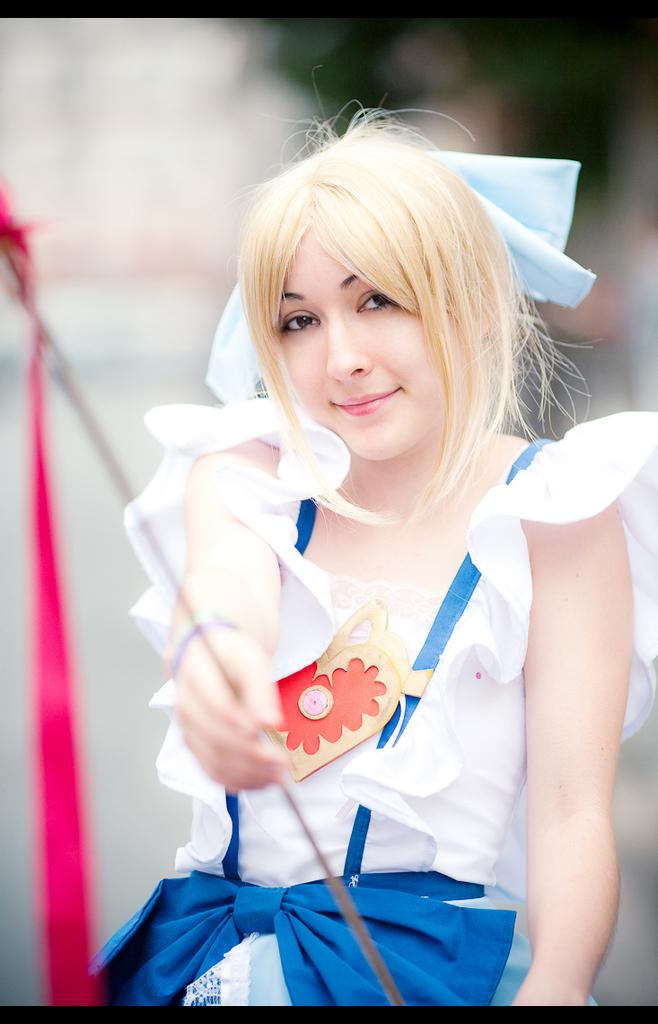Who is the main subject in the image? There is a girl in the image. What is the girl holding in the image? The girl is holding an object. Can you describe the background of the image? The background of the image is blurred. Is there a beggar in the image? There is no mention of a beggar in the provided facts, so we cannot determine if there is one in the image. 